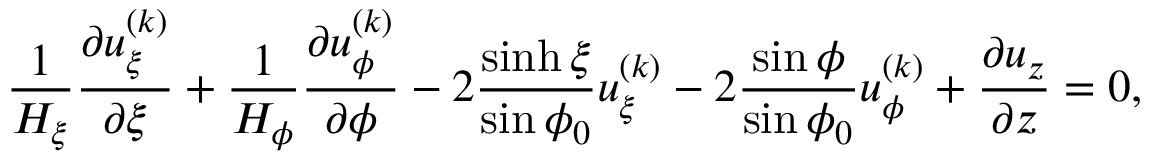Convert formula to latex. <formula><loc_0><loc_0><loc_500><loc_500>\frac { 1 } { H _ { \xi } } \frac { \partial u _ { \xi } ^ { ( k ) } } { \partial \xi } + \frac { 1 } { H _ { \phi } } \frac { \partial u _ { \phi } ^ { ( k ) } } { \partial \phi } - 2 \frac { \sinh \xi } { \sin \phi _ { 0 } } u _ { \xi } ^ { ( k ) } - 2 \frac { \sin \phi } { \sin \phi _ { 0 } } u _ { \phi } ^ { ( k ) } + \frac { \partial u _ { z } } { \partial z } = 0 ,</formula> 